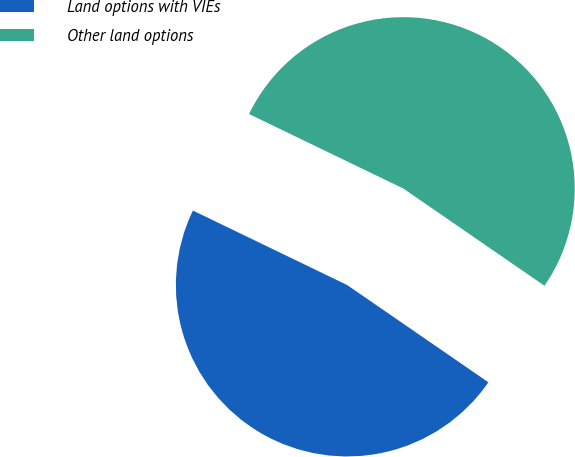<chart> <loc_0><loc_0><loc_500><loc_500><pie_chart><fcel>Land options with VIEs<fcel>Other land options<nl><fcel>47.56%<fcel>52.44%<nl></chart> 